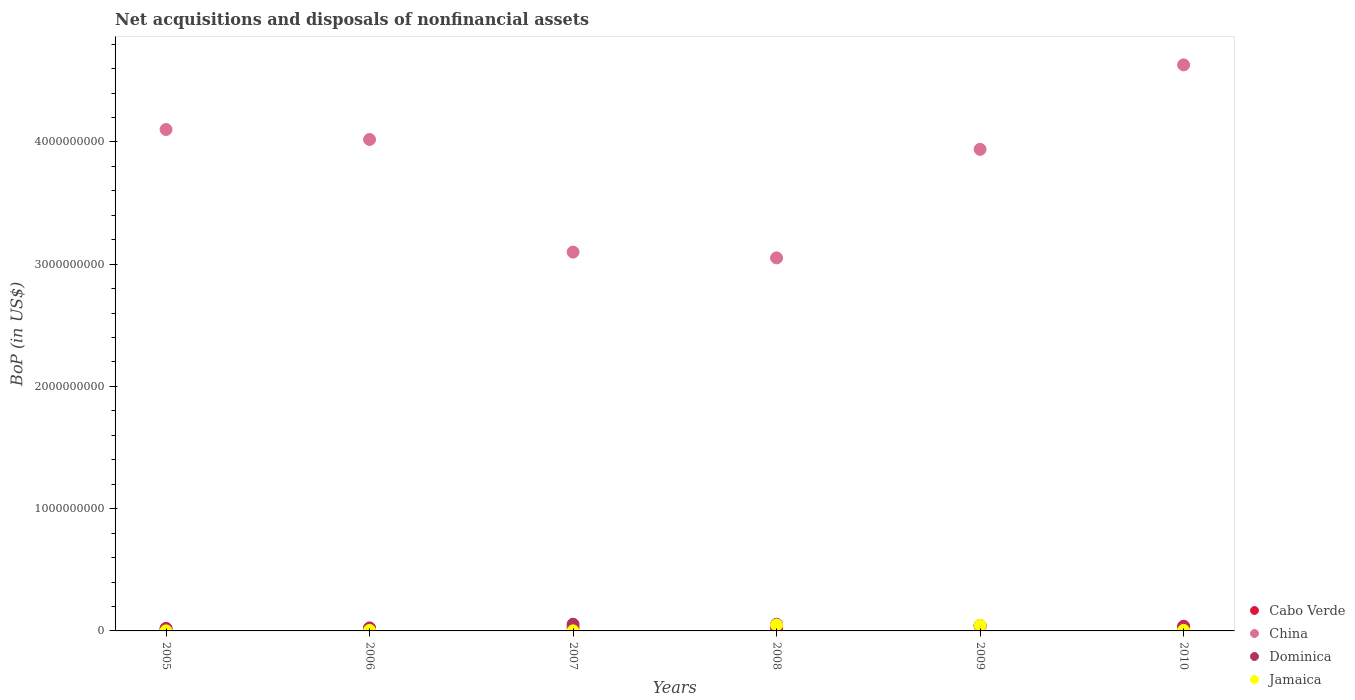Is the number of dotlines equal to the number of legend labels?
Offer a terse response. Yes. What is the Balance of Payments in Dominica in 2007?
Your answer should be compact. 5.47e+07. Across all years, what is the maximum Balance of Payments in China?
Your response must be concise. 4.63e+09. Across all years, what is the minimum Balance of Payments in China?
Provide a short and direct response. 3.05e+09. In which year was the Balance of Payments in Jamaica maximum?
Your response must be concise. 2008. In which year was the Balance of Payments in Cabo Verde minimum?
Ensure brevity in your answer.  2006. What is the total Balance of Payments in Cabo Verde in the graph?
Ensure brevity in your answer.  1.75e+08. What is the difference between the Balance of Payments in Dominica in 2008 and that in 2010?
Keep it short and to the point. 2.41e+07. What is the difference between the Balance of Payments in Dominica in 2008 and the Balance of Payments in China in 2010?
Provide a short and direct response. -4.58e+09. What is the average Balance of Payments in China per year?
Your response must be concise. 3.81e+09. In the year 2006, what is the difference between the Balance of Payments in Jamaica and Balance of Payments in Cabo Verde?
Your answer should be very brief. -1.34e+07. In how many years, is the Balance of Payments in Dominica greater than 3600000000 US$?
Give a very brief answer. 0. What is the ratio of the Balance of Payments in Cabo Verde in 2007 to that in 2010?
Offer a terse response. 0.71. Is the difference between the Balance of Payments in Jamaica in 2007 and 2008 greater than the difference between the Balance of Payments in Cabo Verde in 2007 and 2008?
Offer a terse response. No. What is the difference between the highest and the second highest Balance of Payments in Jamaica?
Offer a very short reply. 3.31e+06. What is the difference between the highest and the lowest Balance of Payments in Dominica?
Provide a short and direct response. 3.95e+07. In how many years, is the Balance of Payments in Dominica greater than the average Balance of Payments in Dominica taken over all years?
Your response must be concise. 3. Is the sum of the Balance of Payments in Dominica in 2007 and 2009 greater than the maximum Balance of Payments in Jamaica across all years?
Provide a succinct answer. Yes. How many dotlines are there?
Offer a very short reply. 4. What is the difference between two consecutive major ticks on the Y-axis?
Give a very brief answer. 1.00e+09. Does the graph contain any zero values?
Your answer should be compact. No. Does the graph contain grids?
Your answer should be very brief. No. Where does the legend appear in the graph?
Your response must be concise. Bottom right. What is the title of the graph?
Provide a short and direct response. Net acquisitions and disposals of nonfinancial assets. Does "Congo (Republic)" appear as one of the legend labels in the graph?
Provide a short and direct response. No. What is the label or title of the Y-axis?
Make the answer very short. BoP (in US$). What is the BoP (in US$) of Cabo Verde in 2005?
Keep it short and to the point. 2.07e+07. What is the BoP (in US$) of China in 2005?
Ensure brevity in your answer.  4.10e+09. What is the BoP (in US$) of Dominica in 2005?
Offer a terse response. 1.52e+07. What is the BoP (in US$) in Cabo Verde in 2006?
Offer a very short reply. 1.75e+07. What is the BoP (in US$) in China in 2006?
Your response must be concise. 4.02e+09. What is the BoP (in US$) in Dominica in 2006?
Ensure brevity in your answer.  2.48e+07. What is the BoP (in US$) in Jamaica in 2006?
Your answer should be compact. 4.09e+06. What is the BoP (in US$) of Cabo Verde in 2007?
Offer a very short reply. 2.70e+07. What is the BoP (in US$) of China in 2007?
Offer a terse response. 3.10e+09. What is the BoP (in US$) of Dominica in 2007?
Make the answer very short. 5.47e+07. What is the BoP (in US$) of Jamaica in 2007?
Your answer should be very brief. 6.90e+05. What is the BoP (in US$) in Cabo Verde in 2008?
Keep it short and to the point. 2.67e+07. What is the BoP (in US$) in China in 2008?
Your answer should be compact. 3.05e+09. What is the BoP (in US$) of Dominica in 2008?
Offer a terse response. 5.43e+07. What is the BoP (in US$) of Jamaica in 2008?
Offer a terse response. 4.86e+07. What is the BoP (in US$) in Cabo Verde in 2009?
Provide a succinct answer. 4.45e+07. What is the BoP (in US$) in China in 2009?
Provide a succinct answer. 3.94e+09. What is the BoP (in US$) of Dominica in 2009?
Ensure brevity in your answer.  4.08e+07. What is the BoP (in US$) of Jamaica in 2009?
Make the answer very short. 4.53e+07. What is the BoP (in US$) of Cabo Verde in 2010?
Provide a succinct answer. 3.83e+07. What is the BoP (in US$) in China in 2010?
Offer a terse response. 4.63e+09. What is the BoP (in US$) of Dominica in 2010?
Give a very brief answer. 3.02e+07. What is the BoP (in US$) in Jamaica in 2010?
Give a very brief answer. 4.24e+06. Across all years, what is the maximum BoP (in US$) in Cabo Verde?
Make the answer very short. 4.45e+07. Across all years, what is the maximum BoP (in US$) of China?
Give a very brief answer. 4.63e+09. Across all years, what is the maximum BoP (in US$) in Dominica?
Your answer should be very brief. 5.47e+07. Across all years, what is the maximum BoP (in US$) in Jamaica?
Your answer should be compact. 4.86e+07. Across all years, what is the minimum BoP (in US$) of Cabo Verde?
Your response must be concise. 1.75e+07. Across all years, what is the minimum BoP (in US$) in China?
Provide a succinct answer. 3.05e+09. Across all years, what is the minimum BoP (in US$) of Dominica?
Offer a terse response. 1.52e+07. Across all years, what is the minimum BoP (in US$) in Jamaica?
Provide a short and direct response. 3.00e+05. What is the total BoP (in US$) of Cabo Verde in the graph?
Provide a succinct answer. 1.75e+08. What is the total BoP (in US$) of China in the graph?
Offer a very short reply. 2.28e+1. What is the total BoP (in US$) of Dominica in the graph?
Offer a terse response. 2.20e+08. What is the total BoP (in US$) of Jamaica in the graph?
Offer a terse response. 1.03e+08. What is the difference between the BoP (in US$) of Cabo Verde in 2005 and that in 2006?
Your answer should be very brief. 3.24e+06. What is the difference between the BoP (in US$) in China in 2005 and that in 2006?
Offer a very short reply. 8.17e+07. What is the difference between the BoP (in US$) in Dominica in 2005 and that in 2006?
Give a very brief answer. -9.58e+06. What is the difference between the BoP (in US$) in Jamaica in 2005 and that in 2006?
Keep it short and to the point. -3.79e+06. What is the difference between the BoP (in US$) in Cabo Verde in 2005 and that in 2007?
Your answer should be very brief. -6.32e+06. What is the difference between the BoP (in US$) in China in 2005 and that in 2007?
Offer a terse response. 1.00e+09. What is the difference between the BoP (in US$) in Dominica in 2005 and that in 2007?
Give a very brief answer. -3.95e+07. What is the difference between the BoP (in US$) of Jamaica in 2005 and that in 2007?
Offer a very short reply. -3.90e+05. What is the difference between the BoP (in US$) of Cabo Verde in 2005 and that in 2008?
Offer a very short reply. -6.04e+06. What is the difference between the BoP (in US$) of China in 2005 and that in 2008?
Offer a very short reply. 1.05e+09. What is the difference between the BoP (in US$) in Dominica in 2005 and that in 2008?
Your answer should be compact. -3.91e+07. What is the difference between the BoP (in US$) in Jamaica in 2005 and that in 2008?
Ensure brevity in your answer.  -4.83e+07. What is the difference between the BoP (in US$) in Cabo Verde in 2005 and that in 2009?
Your answer should be very brief. -2.38e+07. What is the difference between the BoP (in US$) of China in 2005 and that in 2009?
Offer a very short reply. 1.62e+08. What is the difference between the BoP (in US$) in Dominica in 2005 and that in 2009?
Offer a terse response. -2.56e+07. What is the difference between the BoP (in US$) of Jamaica in 2005 and that in 2009?
Offer a very short reply. -4.50e+07. What is the difference between the BoP (in US$) in Cabo Verde in 2005 and that in 2010?
Keep it short and to the point. -1.75e+07. What is the difference between the BoP (in US$) in China in 2005 and that in 2010?
Give a very brief answer. -5.29e+08. What is the difference between the BoP (in US$) of Dominica in 2005 and that in 2010?
Your response must be concise. -1.50e+07. What is the difference between the BoP (in US$) in Jamaica in 2005 and that in 2010?
Ensure brevity in your answer.  -3.94e+06. What is the difference between the BoP (in US$) of Cabo Verde in 2006 and that in 2007?
Your answer should be compact. -9.56e+06. What is the difference between the BoP (in US$) of China in 2006 and that in 2007?
Provide a short and direct response. 9.21e+08. What is the difference between the BoP (in US$) in Dominica in 2006 and that in 2007?
Make the answer very short. -2.99e+07. What is the difference between the BoP (in US$) of Jamaica in 2006 and that in 2007?
Offer a terse response. 3.40e+06. What is the difference between the BoP (in US$) of Cabo Verde in 2006 and that in 2008?
Your answer should be very brief. -9.28e+06. What is the difference between the BoP (in US$) in China in 2006 and that in 2008?
Offer a terse response. 9.69e+08. What is the difference between the BoP (in US$) in Dominica in 2006 and that in 2008?
Your answer should be compact. -2.95e+07. What is the difference between the BoP (in US$) of Jamaica in 2006 and that in 2008?
Keep it short and to the point. -4.45e+07. What is the difference between the BoP (in US$) in Cabo Verde in 2006 and that in 2009?
Ensure brevity in your answer.  -2.70e+07. What is the difference between the BoP (in US$) in China in 2006 and that in 2009?
Your answer should be compact. 8.08e+07. What is the difference between the BoP (in US$) in Dominica in 2006 and that in 2009?
Keep it short and to the point. -1.60e+07. What is the difference between the BoP (in US$) in Jamaica in 2006 and that in 2009?
Keep it short and to the point. -4.12e+07. What is the difference between the BoP (in US$) of Cabo Verde in 2006 and that in 2010?
Offer a terse response. -2.08e+07. What is the difference between the BoP (in US$) of China in 2006 and that in 2010?
Give a very brief answer. -6.10e+08. What is the difference between the BoP (in US$) of Dominica in 2006 and that in 2010?
Offer a very short reply. -5.40e+06. What is the difference between the BoP (in US$) of Jamaica in 2006 and that in 2010?
Your answer should be very brief. -1.52e+05. What is the difference between the BoP (in US$) of Cabo Verde in 2007 and that in 2008?
Keep it short and to the point. 2.85e+05. What is the difference between the BoP (in US$) in China in 2007 and that in 2008?
Provide a succinct answer. 4.76e+07. What is the difference between the BoP (in US$) in Dominica in 2007 and that in 2008?
Your answer should be compact. 4.48e+05. What is the difference between the BoP (in US$) in Jamaica in 2007 and that in 2008?
Your answer should be very brief. -4.79e+07. What is the difference between the BoP (in US$) of Cabo Verde in 2007 and that in 2009?
Your answer should be very brief. -1.75e+07. What is the difference between the BoP (in US$) of China in 2007 and that in 2009?
Make the answer very short. -8.40e+08. What is the difference between the BoP (in US$) of Dominica in 2007 and that in 2009?
Offer a very short reply. 1.39e+07. What is the difference between the BoP (in US$) in Jamaica in 2007 and that in 2009?
Keep it short and to the point. -4.46e+07. What is the difference between the BoP (in US$) of Cabo Verde in 2007 and that in 2010?
Ensure brevity in your answer.  -1.12e+07. What is the difference between the BoP (in US$) in China in 2007 and that in 2010?
Keep it short and to the point. -1.53e+09. What is the difference between the BoP (in US$) of Dominica in 2007 and that in 2010?
Your answer should be very brief. 2.45e+07. What is the difference between the BoP (in US$) in Jamaica in 2007 and that in 2010?
Provide a short and direct response. -3.55e+06. What is the difference between the BoP (in US$) of Cabo Verde in 2008 and that in 2009?
Keep it short and to the point. -1.77e+07. What is the difference between the BoP (in US$) of China in 2008 and that in 2009?
Ensure brevity in your answer.  -8.88e+08. What is the difference between the BoP (in US$) in Dominica in 2008 and that in 2009?
Your response must be concise. 1.35e+07. What is the difference between the BoP (in US$) of Jamaica in 2008 and that in 2009?
Your response must be concise. 3.31e+06. What is the difference between the BoP (in US$) in Cabo Verde in 2008 and that in 2010?
Provide a short and direct response. -1.15e+07. What is the difference between the BoP (in US$) of China in 2008 and that in 2010?
Give a very brief answer. -1.58e+09. What is the difference between the BoP (in US$) in Dominica in 2008 and that in 2010?
Provide a succinct answer. 2.41e+07. What is the difference between the BoP (in US$) of Jamaica in 2008 and that in 2010?
Give a very brief answer. 4.43e+07. What is the difference between the BoP (in US$) in Cabo Verde in 2009 and that in 2010?
Provide a succinct answer. 6.24e+06. What is the difference between the BoP (in US$) in China in 2009 and that in 2010?
Your answer should be very brief. -6.91e+08. What is the difference between the BoP (in US$) in Dominica in 2009 and that in 2010?
Your answer should be compact. 1.06e+07. What is the difference between the BoP (in US$) in Jamaica in 2009 and that in 2010?
Ensure brevity in your answer.  4.10e+07. What is the difference between the BoP (in US$) in Cabo Verde in 2005 and the BoP (in US$) in China in 2006?
Offer a terse response. -4.00e+09. What is the difference between the BoP (in US$) in Cabo Verde in 2005 and the BoP (in US$) in Dominica in 2006?
Provide a short and direct response. -4.10e+06. What is the difference between the BoP (in US$) in Cabo Verde in 2005 and the BoP (in US$) in Jamaica in 2006?
Your response must be concise. 1.66e+07. What is the difference between the BoP (in US$) in China in 2005 and the BoP (in US$) in Dominica in 2006?
Make the answer very short. 4.08e+09. What is the difference between the BoP (in US$) in China in 2005 and the BoP (in US$) in Jamaica in 2006?
Make the answer very short. 4.10e+09. What is the difference between the BoP (in US$) in Dominica in 2005 and the BoP (in US$) in Jamaica in 2006?
Your answer should be compact. 1.11e+07. What is the difference between the BoP (in US$) of Cabo Verde in 2005 and the BoP (in US$) of China in 2007?
Make the answer very short. -3.08e+09. What is the difference between the BoP (in US$) of Cabo Verde in 2005 and the BoP (in US$) of Dominica in 2007?
Make the answer very short. -3.40e+07. What is the difference between the BoP (in US$) of Cabo Verde in 2005 and the BoP (in US$) of Jamaica in 2007?
Offer a terse response. 2.00e+07. What is the difference between the BoP (in US$) of China in 2005 and the BoP (in US$) of Dominica in 2007?
Provide a short and direct response. 4.05e+09. What is the difference between the BoP (in US$) in China in 2005 and the BoP (in US$) in Jamaica in 2007?
Offer a terse response. 4.10e+09. What is the difference between the BoP (in US$) in Dominica in 2005 and the BoP (in US$) in Jamaica in 2007?
Offer a very short reply. 1.45e+07. What is the difference between the BoP (in US$) of Cabo Verde in 2005 and the BoP (in US$) of China in 2008?
Make the answer very short. -3.03e+09. What is the difference between the BoP (in US$) of Cabo Verde in 2005 and the BoP (in US$) of Dominica in 2008?
Provide a short and direct response. -3.36e+07. What is the difference between the BoP (in US$) of Cabo Verde in 2005 and the BoP (in US$) of Jamaica in 2008?
Provide a short and direct response. -2.79e+07. What is the difference between the BoP (in US$) of China in 2005 and the BoP (in US$) of Dominica in 2008?
Make the answer very short. 4.05e+09. What is the difference between the BoP (in US$) in China in 2005 and the BoP (in US$) in Jamaica in 2008?
Your response must be concise. 4.05e+09. What is the difference between the BoP (in US$) of Dominica in 2005 and the BoP (in US$) of Jamaica in 2008?
Your answer should be compact. -3.33e+07. What is the difference between the BoP (in US$) in Cabo Verde in 2005 and the BoP (in US$) in China in 2009?
Provide a succinct answer. -3.92e+09. What is the difference between the BoP (in US$) in Cabo Verde in 2005 and the BoP (in US$) in Dominica in 2009?
Your response must be concise. -2.01e+07. What is the difference between the BoP (in US$) in Cabo Verde in 2005 and the BoP (in US$) in Jamaica in 2009?
Your response must be concise. -2.45e+07. What is the difference between the BoP (in US$) in China in 2005 and the BoP (in US$) in Dominica in 2009?
Keep it short and to the point. 4.06e+09. What is the difference between the BoP (in US$) of China in 2005 and the BoP (in US$) of Jamaica in 2009?
Your response must be concise. 4.06e+09. What is the difference between the BoP (in US$) of Dominica in 2005 and the BoP (in US$) of Jamaica in 2009?
Your answer should be very brief. -3.00e+07. What is the difference between the BoP (in US$) of Cabo Verde in 2005 and the BoP (in US$) of China in 2010?
Offer a very short reply. -4.61e+09. What is the difference between the BoP (in US$) in Cabo Verde in 2005 and the BoP (in US$) in Dominica in 2010?
Provide a succinct answer. -9.51e+06. What is the difference between the BoP (in US$) in Cabo Verde in 2005 and the BoP (in US$) in Jamaica in 2010?
Your answer should be very brief. 1.65e+07. What is the difference between the BoP (in US$) of China in 2005 and the BoP (in US$) of Dominica in 2010?
Your answer should be very brief. 4.07e+09. What is the difference between the BoP (in US$) of China in 2005 and the BoP (in US$) of Jamaica in 2010?
Give a very brief answer. 4.10e+09. What is the difference between the BoP (in US$) of Dominica in 2005 and the BoP (in US$) of Jamaica in 2010?
Ensure brevity in your answer.  1.10e+07. What is the difference between the BoP (in US$) in Cabo Verde in 2006 and the BoP (in US$) in China in 2007?
Make the answer very short. -3.08e+09. What is the difference between the BoP (in US$) in Cabo Verde in 2006 and the BoP (in US$) in Dominica in 2007?
Your answer should be very brief. -3.73e+07. What is the difference between the BoP (in US$) of Cabo Verde in 2006 and the BoP (in US$) of Jamaica in 2007?
Provide a short and direct response. 1.68e+07. What is the difference between the BoP (in US$) in China in 2006 and the BoP (in US$) in Dominica in 2007?
Provide a short and direct response. 3.97e+09. What is the difference between the BoP (in US$) in China in 2006 and the BoP (in US$) in Jamaica in 2007?
Ensure brevity in your answer.  4.02e+09. What is the difference between the BoP (in US$) of Dominica in 2006 and the BoP (in US$) of Jamaica in 2007?
Keep it short and to the point. 2.41e+07. What is the difference between the BoP (in US$) in Cabo Verde in 2006 and the BoP (in US$) in China in 2008?
Give a very brief answer. -3.03e+09. What is the difference between the BoP (in US$) in Cabo Verde in 2006 and the BoP (in US$) in Dominica in 2008?
Your response must be concise. -3.68e+07. What is the difference between the BoP (in US$) of Cabo Verde in 2006 and the BoP (in US$) of Jamaica in 2008?
Make the answer very short. -3.11e+07. What is the difference between the BoP (in US$) in China in 2006 and the BoP (in US$) in Dominica in 2008?
Keep it short and to the point. 3.97e+09. What is the difference between the BoP (in US$) in China in 2006 and the BoP (in US$) in Jamaica in 2008?
Ensure brevity in your answer.  3.97e+09. What is the difference between the BoP (in US$) of Dominica in 2006 and the BoP (in US$) of Jamaica in 2008?
Your answer should be very brief. -2.38e+07. What is the difference between the BoP (in US$) in Cabo Verde in 2006 and the BoP (in US$) in China in 2009?
Ensure brevity in your answer.  -3.92e+09. What is the difference between the BoP (in US$) of Cabo Verde in 2006 and the BoP (in US$) of Dominica in 2009?
Provide a succinct answer. -2.34e+07. What is the difference between the BoP (in US$) of Cabo Verde in 2006 and the BoP (in US$) of Jamaica in 2009?
Provide a short and direct response. -2.78e+07. What is the difference between the BoP (in US$) of China in 2006 and the BoP (in US$) of Dominica in 2009?
Your answer should be very brief. 3.98e+09. What is the difference between the BoP (in US$) in China in 2006 and the BoP (in US$) in Jamaica in 2009?
Your answer should be very brief. 3.97e+09. What is the difference between the BoP (in US$) of Dominica in 2006 and the BoP (in US$) of Jamaica in 2009?
Keep it short and to the point. -2.04e+07. What is the difference between the BoP (in US$) in Cabo Verde in 2006 and the BoP (in US$) in China in 2010?
Make the answer very short. -4.61e+09. What is the difference between the BoP (in US$) of Cabo Verde in 2006 and the BoP (in US$) of Dominica in 2010?
Keep it short and to the point. -1.27e+07. What is the difference between the BoP (in US$) of Cabo Verde in 2006 and the BoP (in US$) of Jamaica in 2010?
Ensure brevity in your answer.  1.32e+07. What is the difference between the BoP (in US$) in China in 2006 and the BoP (in US$) in Dominica in 2010?
Make the answer very short. 3.99e+09. What is the difference between the BoP (in US$) in China in 2006 and the BoP (in US$) in Jamaica in 2010?
Offer a very short reply. 4.02e+09. What is the difference between the BoP (in US$) in Dominica in 2006 and the BoP (in US$) in Jamaica in 2010?
Give a very brief answer. 2.06e+07. What is the difference between the BoP (in US$) of Cabo Verde in 2007 and the BoP (in US$) of China in 2008?
Provide a short and direct response. -3.02e+09. What is the difference between the BoP (in US$) of Cabo Verde in 2007 and the BoP (in US$) of Dominica in 2008?
Your response must be concise. -2.73e+07. What is the difference between the BoP (in US$) in Cabo Verde in 2007 and the BoP (in US$) in Jamaica in 2008?
Your response must be concise. -2.15e+07. What is the difference between the BoP (in US$) of China in 2007 and the BoP (in US$) of Dominica in 2008?
Your response must be concise. 3.04e+09. What is the difference between the BoP (in US$) of China in 2007 and the BoP (in US$) of Jamaica in 2008?
Provide a succinct answer. 3.05e+09. What is the difference between the BoP (in US$) in Dominica in 2007 and the BoP (in US$) in Jamaica in 2008?
Keep it short and to the point. 6.18e+06. What is the difference between the BoP (in US$) in Cabo Verde in 2007 and the BoP (in US$) in China in 2009?
Make the answer very short. -3.91e+09. What is the difference between the BoP (in US$) in Cabo Verde in 2007 and the BoP (in US$) in Dominica in 2009?
Keep it short and to the point. -1.38e+07. What is the difference between the BoP (in US$) of Cabo Verde in 2007 and the BoP (in US$) of Jamaica in 2009?
Keep it short and to the point. -1.82e+07. What is the difference between the BoP (in US$) in China in 2007 and the BoP (in US$) in Dominica in 2009?
Provide a succinct answer. 3.06e+09. What is the difference between the BoP (in US$) of China in 2007 and the BoP (in US$) of Jamaica in 2009?
Ensure brevity in your answer.  3.05e+09. What is the difference between the BoP (in US$) in Dominica in 2007 and the BoP (in US$) in Jamaica in 2009?
Keep it short and to the point. 9.49e+06. What is the difference between the BoP (in US$) in Cabo Verde in 2007 and the BoP (in US$) in China in 2010?
Offer a terse response. -4.60e+09. What is the difference between the BoP (in US$) of Cabo Verde in 2007 and the BoP (in US$) of Dominica in 2010?
Give a very brief answer. -3.18e+06. What is the difference between the BoP (in US$) in Cabo Verde in 2007 and the BoP (in US$) in Jamaica in 2010?
Your response must be concise. 2.28e+07. What is the difference between the BoP (in US$) in China in 2007 and the BoP (in US$) in Dominica in 2010?
Keep it short and to the point. 3.07e+09. What is the difference between the BoP (in US$) of China in 2007 and the BoP (in US$) of Jamaica in 2010?
Offer a very short reply. 3.09e+09. What is the difference between the BoP (in US$) in Dominica in 2007 and the BoP (in US$) in Jamaica in 2010?
Keep it short and to the point. 5.05e+07. What is the difference between the BoP (in US$) of Cabo Verde in 2008 and the BoP (in US$) of China in 2009?
Keep it short and to the point. -3.91e+09. What is the difference between the BoP (in US$) in Cabo Verde in 2008 and the BoP (in US$) in Dominica in 2009?
Provide a succinct answer. -1.41e+07. What is the difference between the BoP (in US$) in Cabo Verde in 2008 and the BoP (in US$) in Jamaica in 2009?
Keep it short and to the point. -1.85e+07. What is the difference between the BoP (in US$) in China in 2008 and the BoP (in US$) in Dominica in 2009?
Your answer should be compact. 3.01e+09. What is the difference between the BoP (in US$) in China in 2008 and the BoP (in US$) in Jamaica in 2009?
Your response must be concise. 3.01e+09. What is the difference between the BoP (in US$) in Dominica in 2008 and the BoP (in US$) in Jamaica in 2009?
Your response must be concise. 9.05e+06. What is the difference between the BoP (in US$) of Cabo Verde in 2008 and the BoP (in US$) of China in 2010?
Provide a succinct answer. -4.60e+09. What is the difference between the BoP (in US$) of Cabo Verde in 2008 and the BoP (in US$) of Dominica in 2010?
Offer a terse response. -3.47e+06. What is the difference between the BoP (in US$) of Cabo Verde in 2008 and the BoP (in US$) of Jamaica in 2010?
Make the answer very short. 2.25e+07. What is the difference between the BoP (in US$) in China in 2008 and the BoP (in US$) in Dominica in 2010?
Your answer should be compact. 3.02e+09. What is the difference between the BoP (in US$) in China in 2008 and the BoP (in US$) in Jamaica in 2010?
Make the answer very short. 3.05e+09. What is the difference between the BoP (in US$) of Dominica in 2008 and the BoP (in US$) of Jamaica in 2010?
Your answer should be very brief. 5.01e+07. What is the difference between the BoP (in US$) of Cabo Verde in 2009 and the BoP (in US$) of China in 2010?
Make the answer very short. -4.59e+09. What is the difference between the BoP (in US$) of Cabo Verde in 2009 and the BoP (in US$) of Dominica in 2010?
Keep it short and to the point. 1.43e+07. What is the difference between the BoP (in US$) of Cabo Verde in 2009 and the BoP (in US$) of Jamaica in 2010?
Your response must be concise. 4.03e+07. What is the difference between the BoP (in US$) in China in 2009 and the BoP (in US$) in Dominica in 2010?
Give a very brief answer. 3.91e+09. What is the difference between the BoP (in US$) of China in 2009 and the BoP (in US$) of Jamaica in 2010?
Your answer should be compact. 3.94e+09. What is the difference between the BoP (in US$) of Dominica in 2009 and the BoP (in US$) of Jamaica in 2010?
Keep it short and to the point. 3.66e+07. What is the average BoP (in US$) of Cabo Verde per year?
Ensure brevity in your answer.  2.91e+07. What is the average BoP (in US$) of China per year?
Give a very brief answer. 3.81e+09. What is the average BoP (in US$) of Dominica per year?
Offer a very short reply. 3.67e+07. What is the average BoP (in US$) of Jamaica per year?
Your response must be concise. 1.72e+07. In the year 2005, what is the difference between the BoP (in US$) of Cabo Verde and BoP (in US$) of China?
Your answer should be very brief. -4.08e+09. In the year 2005, what is the difference between the BoP (in US$) in Cabo Verde and BoP (in US$) in Dominica?
Offer a very short reply. 5.48e+06. In the year 2005, what is the difference between the BoP (in US$) of Cabo Verde and BoP (in US$) of Jamaica?
Give a very brief answer. 2.04e+07. In the year 2005, what is the difference between the BoP (in US$) of China and BoP (in US$) of Dominica?
Make the answer very short. 4.09e+09. In the year 2005, what is the difference between the BoP (in US$) of China and BoP (in US$) of Jamaica?
Give a very brief answer. 4.10e+09. In the year 2005, what is the difference between the BoP (in US$) of Dominica and BoP (in US$) of Jamaica?
Provide a short and direct response. 1.49e+07. In the year 2006, what is the difference between the BoP (in US$) in Cabo Verde and BoP (in US$) in China?
Give a very brief answer. -4.00e+09. In the year 2006, what is the difference between the BoP (in US$) of Cabo Verde and BoP (in US$) of Dominica?
Ensure brevity in your answer.  -7.34e+06. In the year 2006, what is the difference between the BoP (in US$) of Cabo Verde and BoP (in US$) of Jamaica?
Your answer should be very brief. 1.34e+07. In the year 2006, what is the difference between the BoP (in US$) in China and BoP (in US$) in Dominica?
Ensure brevity in your answer.  4.00e+09. In the year 2006, what is the difference between the BoP (in US$) in China and BoP (in US$) in Jamaica?
Provide a succinct answer. 4.02e+09. In the year 2006, what is the difference between the BoP (in US$) of Dominica and BoP (in US$) of Jamaica?
Offer a terse response. 2.07e+07. In the year 2007, what is the difference between the BoP (in US$) of Cabo Verde and BoP (in US$) of China?
Keep it short and to the point. -3.07e+09. In the year 2007, what is the difference between the BoP (in US$) in Cabo Verde and BoP (in US$) in Dominica?
Your answer should be compact. -2.77e+07. In the year 2007, what is the difference between the BoP (in US$) of Cabo Verde and BoP (in US$) of Jamaica?
Offer a very short reply. 2.63e+07. In the year 2007, what is the difference between the BoP (in US$) of China and BoP (in US$) of Dominica?
Your response must be concise. 3.04e+09. In the year 2007, what is the difference between the BoP (in US$) of China and BoP (in US$) of Jamaica?
Keep it short and to the point. 3.10e+09. In the year 2007, what is the difference between the BoP (in US$) in Dominica and BoP (in US$) in Jamaica?
Ensure brevity in your answer.  5.41e+07. In the year 2008, what is the difference between the BoP (in US$) in Cabo Verde and BoP (in US$) in China?
Give a very brief answer. -3.02e+09. In the year 2008, what is the difference between the BoP (in US$) of Cabo Verde and BoP (in US$) of Dominica?
Keep it short and to the point. -2.76e+07. In the year 2008, what is the difference between the BoP (in US$) in Cabo Verde and BoP (in US$) in Jamaica?
Ensure brevity in your answer.  -2.18e+07. In the year 2008, what is the difference between the BoP (in US$) of China and BoP (in US$) of Dominica?
Provide a short and direct response. 3.00e+09. In the year 2008, what is the difference between the BoP (in US$) of China and BoP (in US$) of Jamaica?
Your response must be concise. 3.00e+09. In the year 2008, what is the difference between the BoP (in US$) of Dominica and BoP (in US$) of Jamaica?
Provide a short and direct response. 5.73e+06. In the year 2009, what is the difference between the BoP (in US$) in Cabo Verde and BoP (in US$) in China?
Offer a terse response. -3.89e+09. In the year 2009, what is the difference between the BoP (in US$) of Cabo Verde and BoP (in US$) of Dominica?
Offer a very short reply. 3.66e+06. In the year 2009, what is the difference between the BoP (in US$) in Cabo Verde and BoP (in US$) in Jamaica?
Offer a terse response. -7.60e+05. In the year 2009, what is the difference between the BoP (in US$) in China and BoP (in US$) in Dominica?
Ensure brevity in your answer.  3.90e+09. In the year 2009, what is the difference between the BoP (in US$) of China and BoP (in US$) of Jamaica?
Offer a terse response. 3.89e+09. In the year 2009, what is the difference between the BoP (in US$) in Dominica and BoP (in US$) in Jamaica?
Give a very brief answer. -4.42e+06. In the year 2010, what is the difference between the BoP (in US$) in Cabo Verde and BoP (in US$) in China?
Make the answer very short. -4.59e+09. In the year 2010, what is the difference between the BoP (in US$) in Cabo Verde and BoP (in US$) in Dominica?
Your answer should be compact. 8.04e+06. In the year 2010, what is the difference between the BoP (in US$) in Cabo Verde and BoP (in US$) in Jamaica?
Offer a very short reply. 3.40e+07. In the year 2010, what is the difference between the BoP (in US$) in China and BoP (in US$) in Dominica?
Offer a very short reply. 4.60e+09. In the year 2010, what is the difference between the BoP (in US$) in China and BoP (in US$) in Jamaica?
Ensure brevity in your answer.  4.63e+09. In the year 2010, what is the difference between the BoP (in US$) of Dominica and BoP (in US$) of Jamaica?
Provide a succinct answer. 2.60e+07. What is the ratio of the BoP (in US$) in Cabo Verde in 2005 to that in 2006?
Provide a succinct answer. 1.19. What is the ratio of the BoP (in US$) in China in 2005 to that in 2006?
Provide a succinct answer. 1.02. What is the ratio of the BoP (in US$) in Dominica in 2005 to that in 2006?
Make the answer very short. 0.61. What is the ratio of the BoP (in US$) of Jamaica in 2005 to that in 2006?
Your answer should be very brief. 0.07. What is the ratio of the BoP (in US$) in Cabo Verde in 2005 to that in 2007?
Your answer should be compact. 0.77. What is the ratio of the BoP (in US$) of China in 2005 to that in 2007?
Keep it short and to the point. 1.32. What is the ratio of the BoP (in US$) of Dominica in 2005 to that in 2007?
Offer a terse response. 0.28. What is the ratio of the BoP (in US$) of Jamaica in 2005 to that in 2007?
Ensure brevity in your answer.  0.43. What is the ratio of the BoP (in US$) of Cabo Verde in 2005 to that in 2008?
Ensure brevity in your answer.  0.77. What is the ratio of the BoP (in US$) in China in 2005 to that in 2008?
Provide a succinct answer. 1.34. What is the ratio of the BoP (in US$) in Dominica in 2005 to that in 2008?
Your answer should be very brief. 0.28. What is the ratio of the BoP (in US$) in Jamaica in 2005 to that in 2008?
Your response must be concise. 0.01. What is the ratio of the BoP (in US$) in Cabo Verde in 2005 to that in 2009?
Make the answer very short. 0.47. What is the ratio of the BoP (in US$) in China in 2005 to that in 2009?
Offer a terse response. 1.04. What is the ratio of the BoP (in US$) in Dominica in 2005 to that in 2009?
Your answer should be compact. 0.37. What is the ratio of the BoP (in US$) in Jamaica in 2005 to that in 2009?
Keep it short and to the point. 0.01. What is the ratio of the BoP (in US$) in Cabo Verde in 2005 to that in 2010?
Ensure brevity in your answer.  0.54. What is the ratio of the BoP (in US$) of China in 2005 to that in 2010?
Offer a terse response. 0.89. What is the ratio of the BoP (in US$) of Dominica in 2005 to that in 2010?
Provide a short and direct response. 0.5. What is the ratio of the BoP (in US$) in Jamaica in 2005 to that in 2010?
Offer a very short reply. 0.07. What is the ratio of the BoP (in US$) of Cabo Verde in 2006 to that in 2007?
Your answer should be very brief. 0.65. What is the ratio of the BoP (in US$) in China in 2006 to that in 2007?
Provide a succinct answer. 1.3. What is the ratio of the BoP (in US$) of Dominica in 2006 to that in 2007?
Your response must be concise. 0.45. What is the ratio of the BoP (in US$) of Jamaica in 2006 to that in 2007?
Your answer should be compact. 5.93. What is the ratio of the BoP (in US$) of Cabo Verde in 2006 to that in 2008?
Make the answer very short. 0.65. What is the ratio of the BoP (in US$) in China in 2006 to that in 2008?
Ensure brevity in your answer.  1.32. What is the ratio of the BoP (in US$) of Dominica in 2006 to that in 2008?
Give a very brief answer. 0.46. What is the ratio of the BoP (in US$) in Jamaica in 2006 to that in 2008?
Ensure brevity in your answer.  0.08. What is the ratio of the BoP (in US$) of Cabo Verde in 2006 to that in 2009?
Keep it short and to the point. 0.39. What is the ratio of the BoP (in US$) in China in 2006 to that in 2009?
Offer a very short reply. 1.02. What is the ratio of the BoP (in US$) of Dominica in 2006 to that in 2009?
Your response must be concise. 0.61. What is the ratio of the BoP (in US$) of Jamaica in 2006 to that in 2009?
Give a very brief answer. 0.09. What is the ratio of the BoP (in US$) in Cabo Verde in 2006 to that in 2010?
Keep it short and to the point. 0.46. What is the ratio of the BoP (in US$) of China in 2006 to that in 2010?
Keep it short and to the point. 0.87. What is the ratio of the BoP (in US$) of Dominica in 2006 to that in 2010?
Provide a short and direct response. 0.82. What is the ratio of the BoP (in US$) in Jamaica in 2006 to that in 2010?
Your answer should be compact. 0.96. What is the ratio of the BoP (in US$) in Cabo Verde in 2007 to that in 2008?
Your answer should be compact. 1.01. What is the ratio of the BoP (in US$) of China in 2007 to that in 2008?
Ensure brevity in your answer.  1.02. What is the ratio of the BoP (in US$) in Dominica in 2007 to that in 2008?
Provide a succinct answer. 1.01. What is the ratio of the BoP (in US$) in Jamaica in 2007 to that in 2008?
Your response must be concise. 0.01. What is the ratio of the BoP (in US$) in Cabo Verde in 2007 to that in 2009?
Make the answer very short. 0.61. What is the ratio of the BoP (in US$) in China in 2007 to that in 2009?
Your answer should be compact. 0.79. What is the ratio of the BoP (in US$) of Dominica in 2007 to that in 2009?
Offer a very short reply. 1.34. What is the ratio of the BoP (in US$) of Jamaica in 2007 to that in 2009?
Offer a very short reply. 0.02. What is the ratio of the BoP (in US$) of Cabo Verde in 2007 to that in 2010?
Make the answer very short. 0.71. What is the ratio of the BoP (in US$) of China in 2007 to that in 2010?
Ensure brevity in your answer.  0.67. What is the ratio of the BoP (in US$) in Dominica in 2007 to that in 2010?
Your response must be concise. 1.81. What is the ratio of the BoP (in US$) in Jamaica in 2007 to that in 2010?
Offer a very short reply. 0.16. What is the ratio of the BoP (in US$) of Cabo Verde in 2008 to that in 2009?
Provide a short and direct response. 0.6. What is the ratio of the BoP (in US$) of China in 2008 to that in 2009?
Provide a short and direct response. 0.77. What is the ratio of the BoP (in US$) in Dominica in 2008 to that in 2009?
Ensure brevity in your answer.  1.33. What is the ratio of the BoP (in US$) in Jamaica in 2008 to that in 2009?
Offer a very short reply. 1.07. What is the ratio of the BoP (in US$) of Cabo Verde in 2008 to that in 2010?
Your answer should be very brief. 0.7. What is the ratio of the BoP (in US$) of China in 2008 to that in 2010?
Offer a terse response. 0.66. What is the ratio of the BoP (in US$) in Dominica in 2008 to that in 2010?
Ensure brevity in your answer.  1.8. What is the ratio of the BoP (in US$) in Jamaica in 2008 to that in 2010?
Offer a very short reply. 11.45. What is the ratio of the BoP (in US$) of Cabo Verde in 2009 to that in 2010?
Your answer should be very brief. 1.16. What is the ratio of the BoP (in US$) of China in 2009 to that in 2010?
Give a very brief answer. 0.85. What is the ratio of the BoP (in US$) in Dominica in 2009 to that in 2010?
Give a very brief answer. 1.35. What is the ratio of the BoP (in US$) in Jamaica in 2009 to that in 2010?
Provide a short and direct response. 10.67. What is the difference between the highest and the second highest BoP (in US$) in Cabo Verde?
Offer a terse response. 6.24e+06. What is the difference between the highest and the second highest BoP (in US$) in China?
Keep it short and to the point. 5.29e+08. What is the difference between the highest and the second highest BoP (in US$) of Dominica?
Make the answer very short. 4.48e+05. What is the difference between the highest and the second highest BoP (in US$) in Jamaica?
Your answer should be compact. 3.31e+06. What is the difference between the highest and the lowest BoP (in US$) of Cabo Verde?
Ensure brevity in your answer.  2.70e+07. What is the difference between the highest and the lowest BoP (in US$) in China?
Provide a succinct answer. 1.58e+09. What is the difference between the highest and the lowest BoP (in US$) in Dominica?
Provide a succinct answer. 3.95e+07. What is the difference between the highest and the lowest BoP (in US$) of Jamaica?
Your response must be concise. 4.83e+07. 